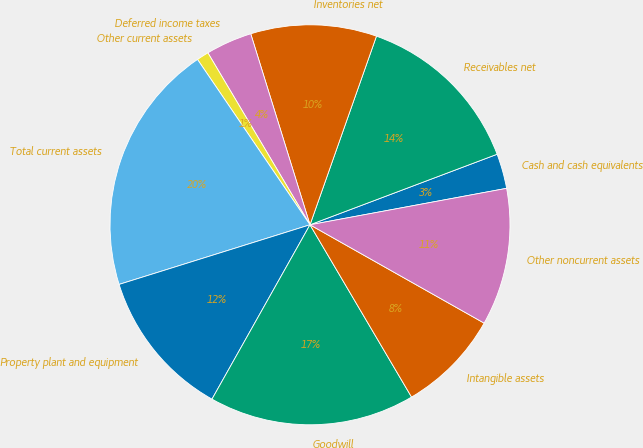Convert chart to OTSL. <chart><loc_0><loc_0><loc_500><loc_500><pie_chart><fcel>Cash and cash equivalents<fcel>Receivables net<fcel>Inventories net<fcel>Deferred income taxes<fcel>Other current assets<fcel>Total current assets<fcel>Property plant and equipment<fcel>Goodwill<fcel>Intangible assets<fcel>Other noncurrent assets<nl><fcel>2.82%<fcel>13.87%<fcel>10.18%<fcel>3.74%<fcel>0.98%<fcel>20.31%<fcel>12.03%<fcel>16.63%<fcel>8.34%<fcel>11.1%<nl></chart> 